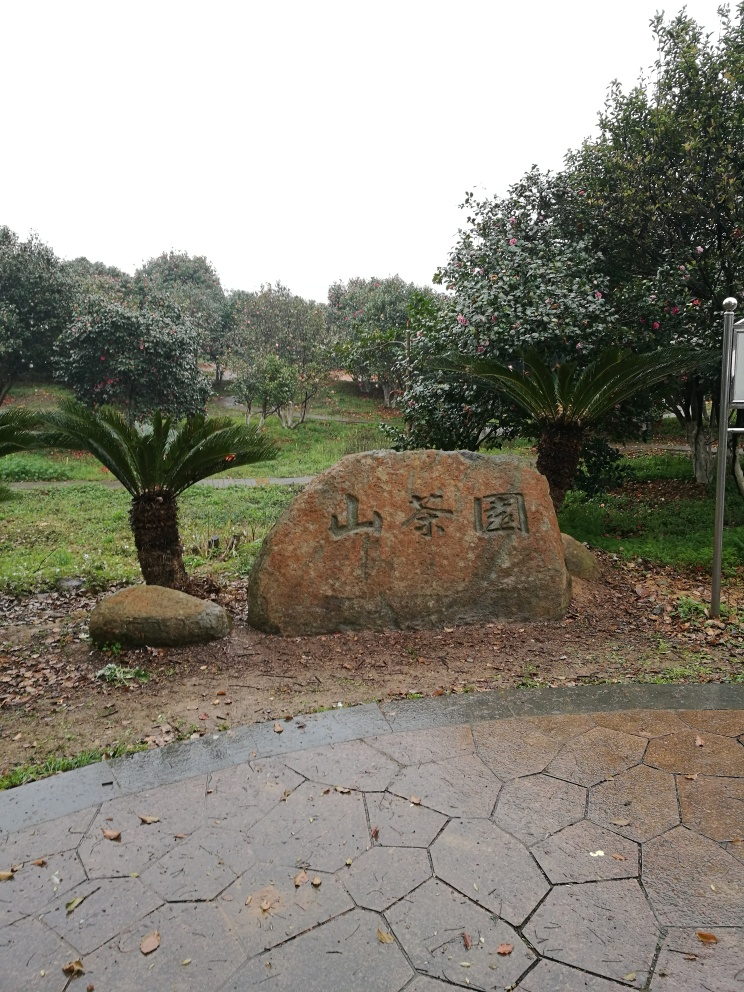How does the weather appear to affect the mood of this photo? The overcast sky and absence of direct sunlight give the image a subdued and calm atmosphere. The lack of harsh shadows and diffused light contribute to the serene quality of the setting, emphasizing the quiet and contemplative mood of the garden. 